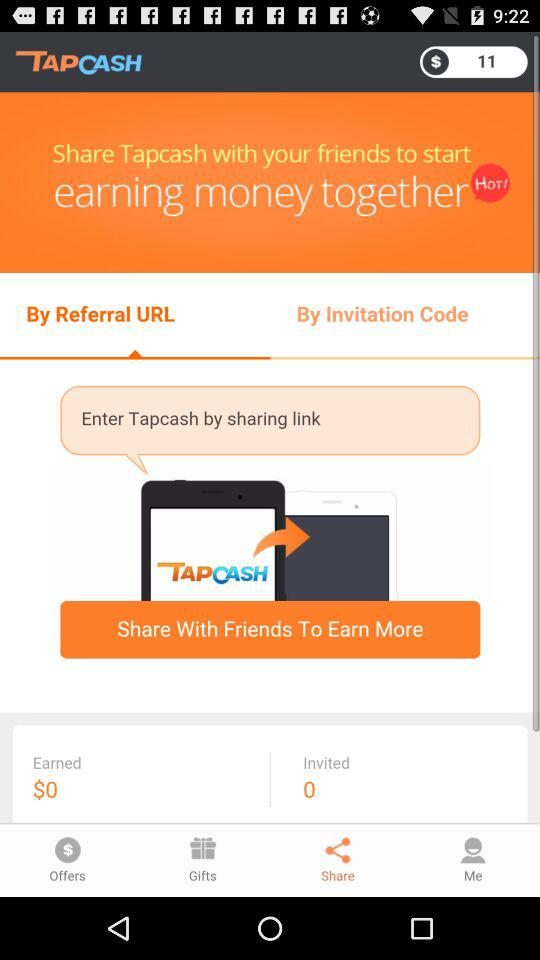How much is the earned money? The earned money is $0. 